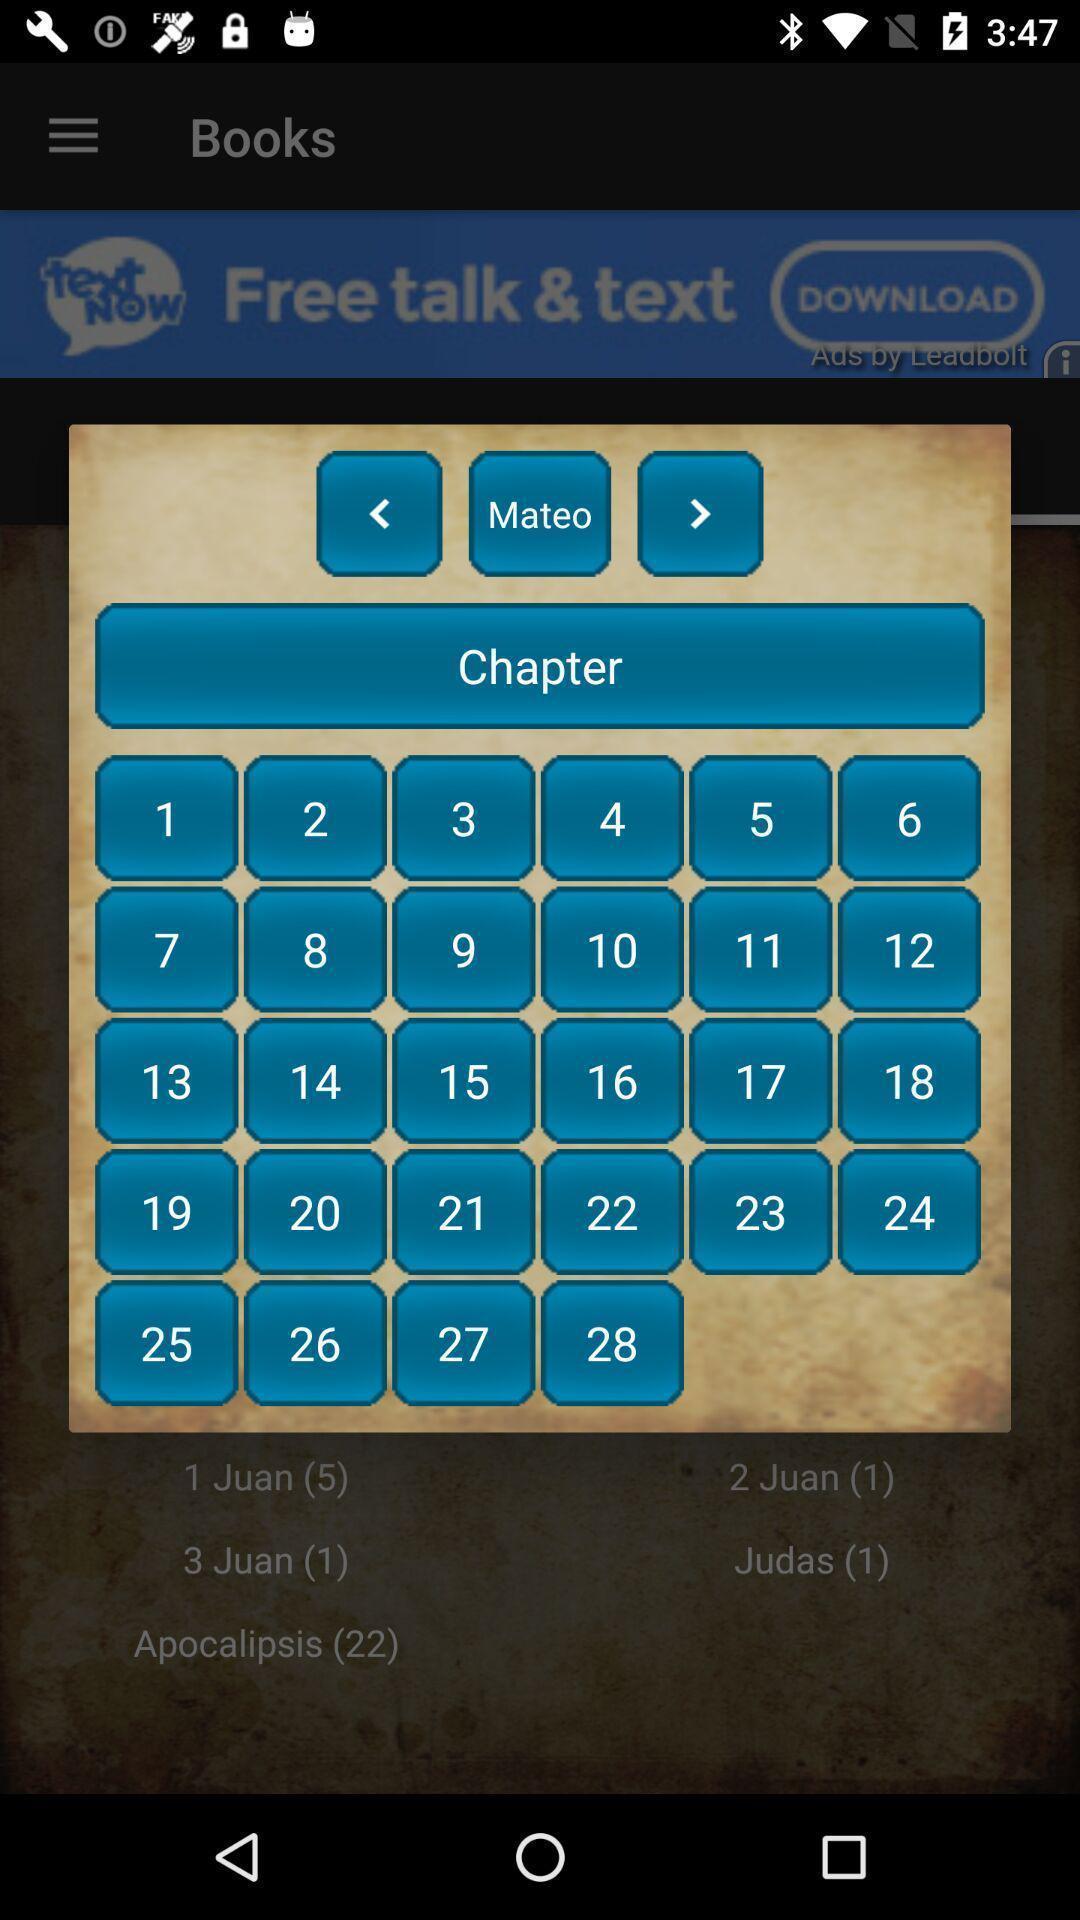Tell me about the visual elements in this screen capture. Pop-up shows different chapters in book. 